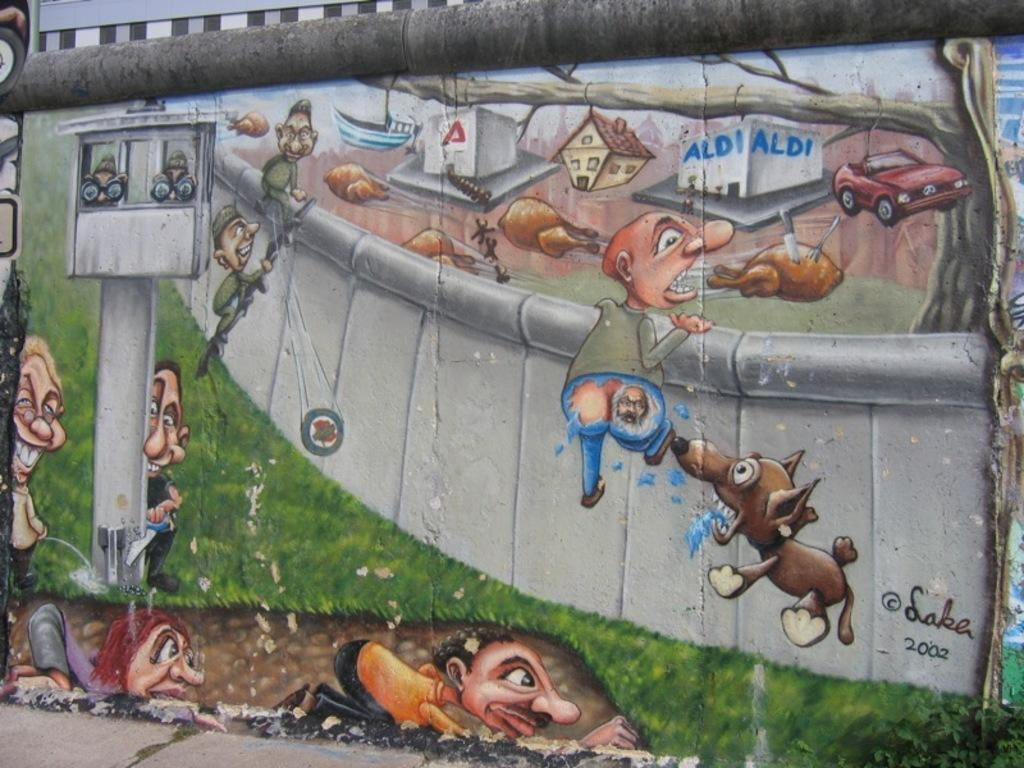What is depicted on the wall in the image? There is a wall painting in the image. What elements are included in the wall painting? The wall painting contains people, a chicken, a car, a house, a pole, and a boat. Can you describe the setting of the wall painting? The wall painting depicts a scene that includes various elements such as a house, a car, a pole, and a boat. What type of dust can be seen on the wall painting in the image? There is no dust visible on the wall painting in the image. What subject is being taught in the wall painting? There is no indication of teaching or any educational subject in the wall painting; it is a painting with various elements. 